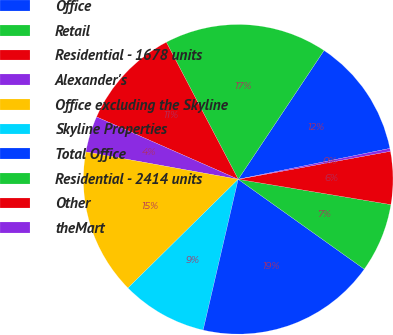<chart> <loc_0><loc_0><loc_500><loc_500><pie_chart><fcel>Office<fcel>Retail<fcel>Residential - 1678 units<fcel>Alexander's<fcel>Office excluding the Skyline<fcel>Skyline Properties<fcel>Total Office<fcel>Residential - 2414 units<fcel>Other<fcel>theMart<nl><fcel>12.45%<fcel>17.04%<fcel>10.71%<fcel>3.77%<fcel>15.22%<fcel>8.98%<fcel>18.78%<fcel>7.24%<fcel>5.51%<fcel>0.3%<nl></chart> 